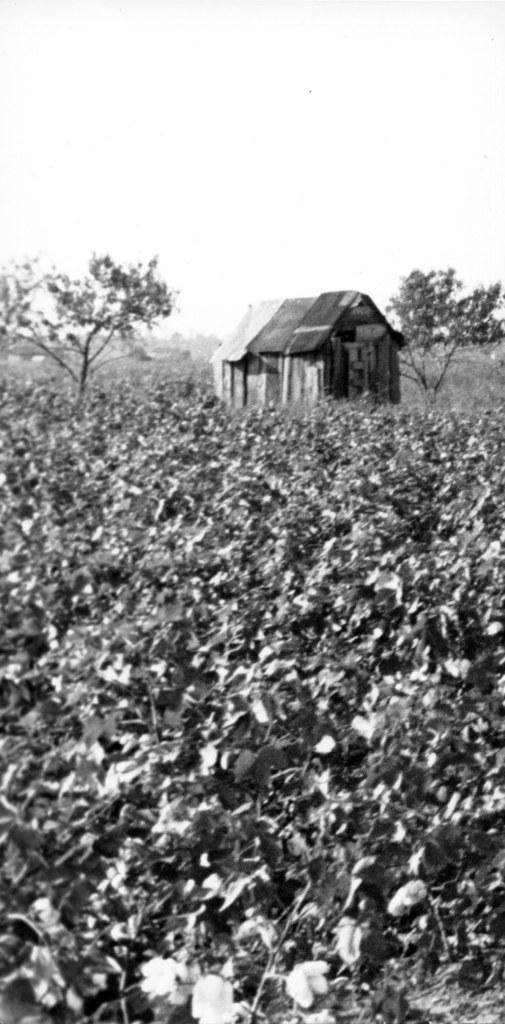What type of living organisms can be seen in the image? Plants can be seen in the image. What structure is visible in the background of the image? There is a shed in the background of the image. What type of vegetation is visible in the background of the image? Trees are visible in the background of the image. What part of the natural environment is visible in the image? The sky is visible in the background of the image. How many cows are smashing the sidewalk in the image? There are no cows or sidewalks present in the image. 